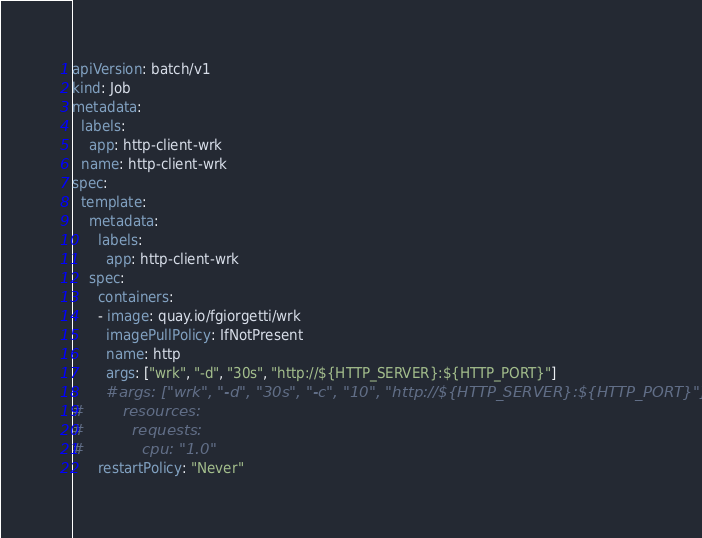Convert code to text. <code><loc_0><loc_0><loc_500><loc_500><_YAML_>apiVersion: batch/v1
kind: Job
metadata:
  labels:
    app: http-client-wrk
  name: http-client-wrk
spec:
  template:
    metadata:
      labels:
        app: http-client-wrk
    spec:
      containers:
      - image: quay.io/fgiorgetti/wrk
        imagePullPolicy: IfNotPresent
        name: http
        args: ["wrk", "-d", "30s", "http://${HTTP_SERVER}:${HTTP_PORT}"]
        #args: ["wrk", "-d", "30s", "-c", "10", "http://${HTTP_SERVER}:${HTTP_PORT}"]
#        resources:
#          requests:
#            cpu: "1.0"
      restartPolicy: "Never"
</code> 